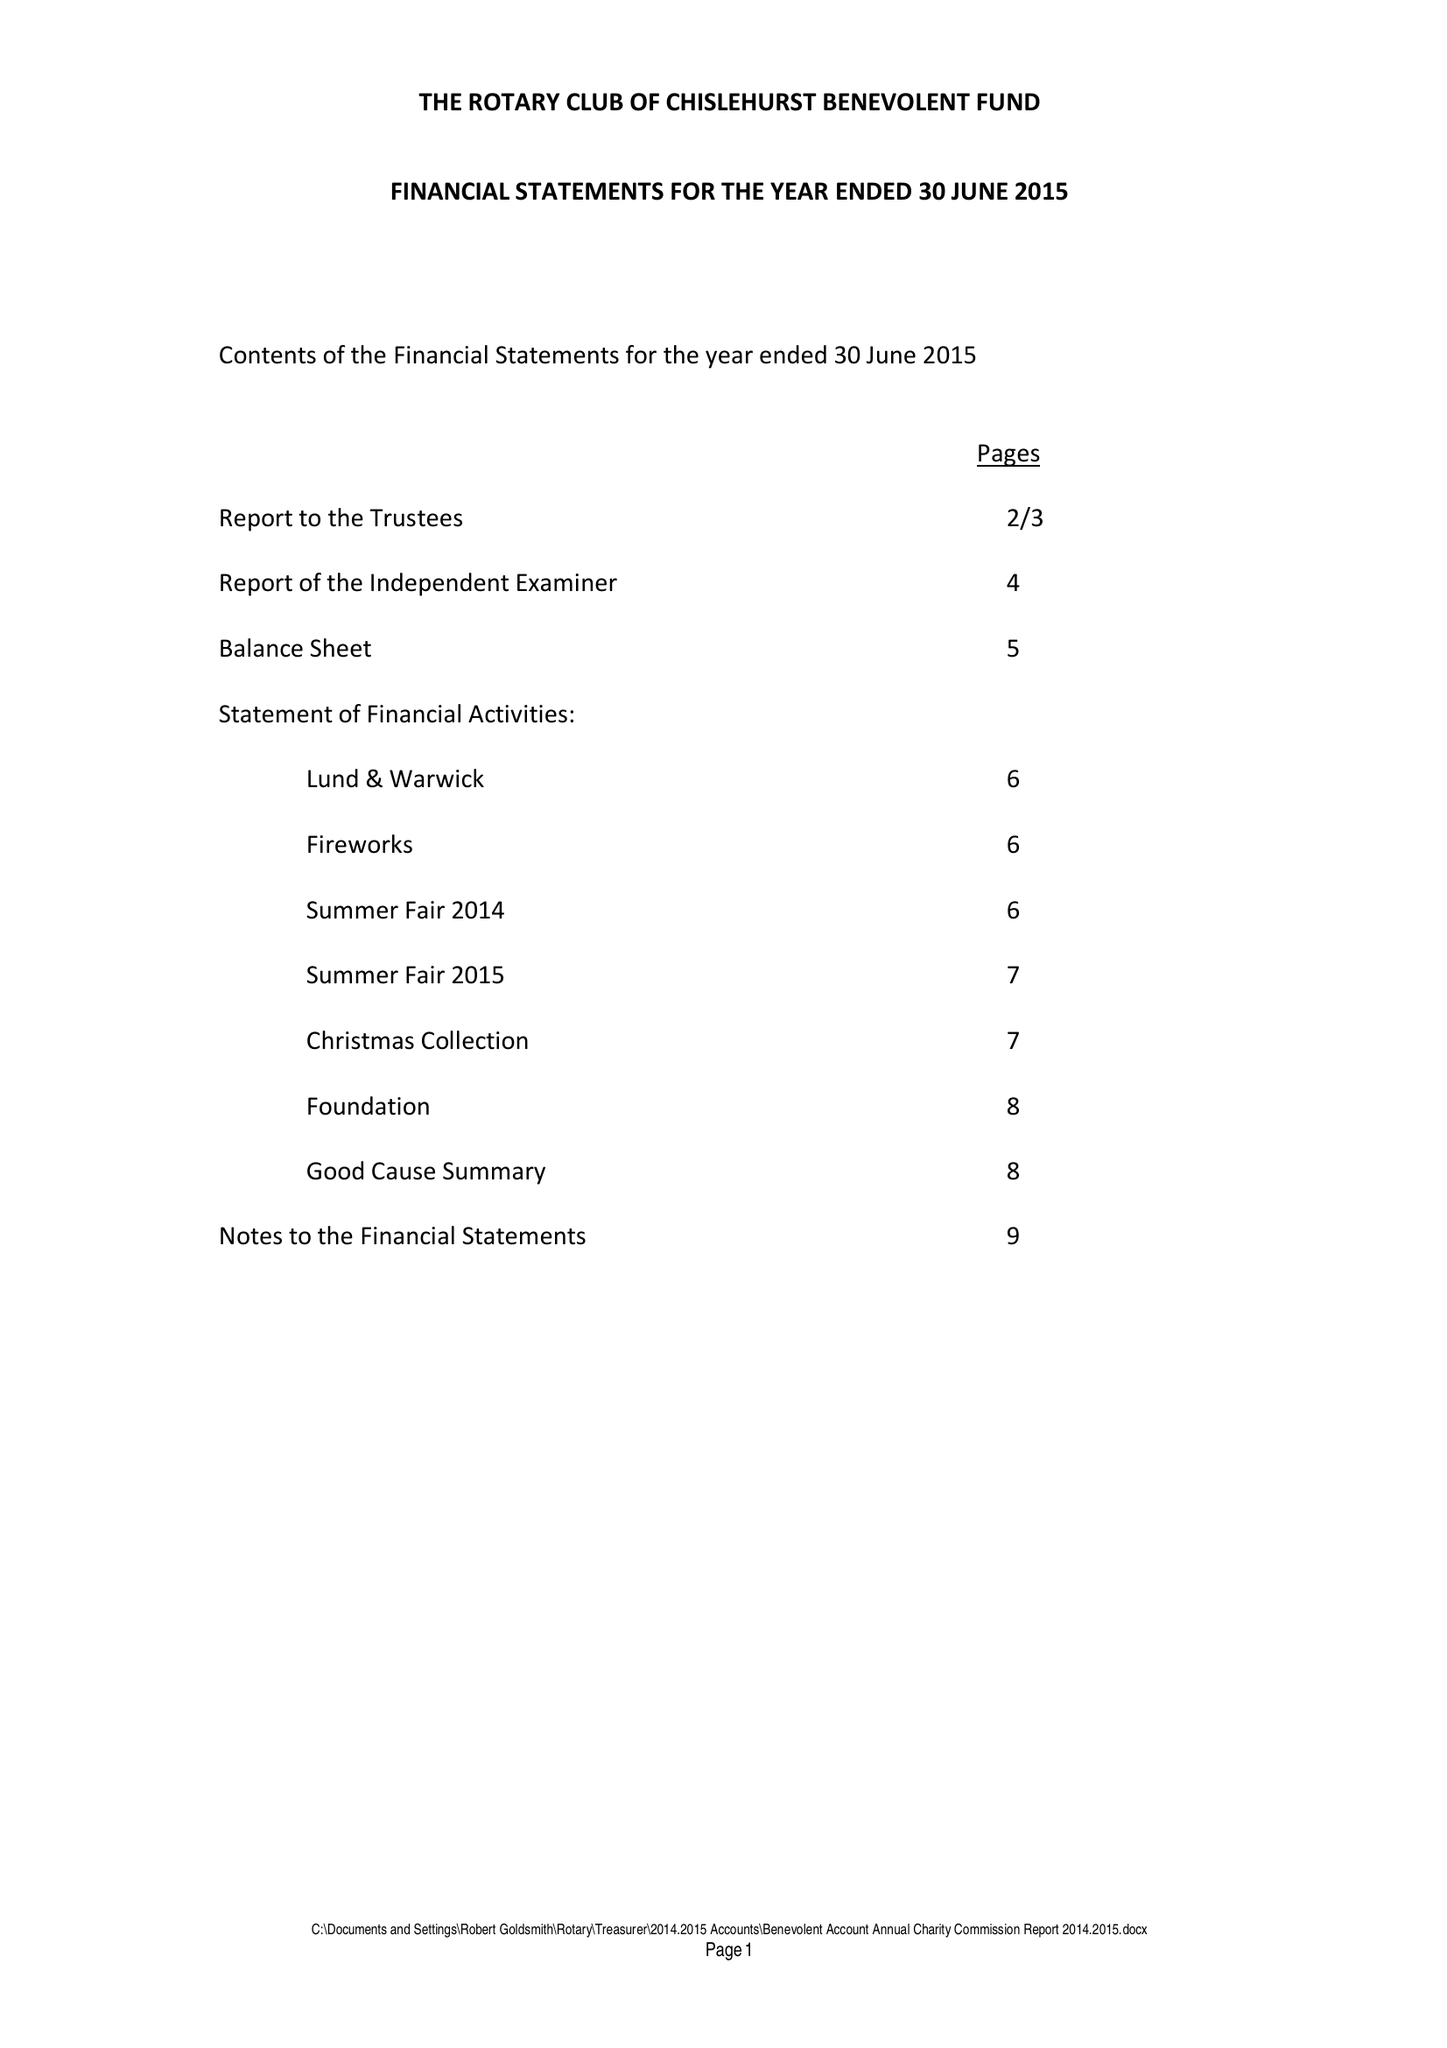What is the value for the spending_annually_in_british_pounds?
Answer the question using a single word or phrase. 42447.00 